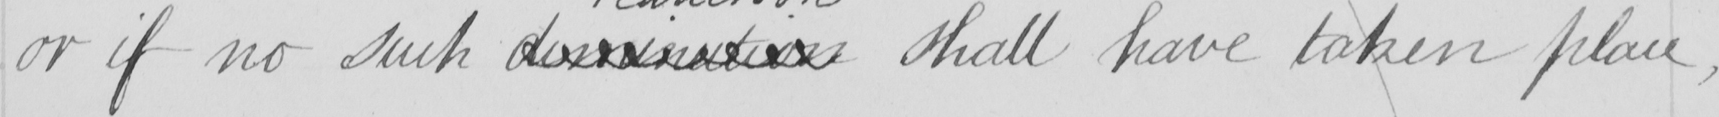Can you read and transcribe this handwriting? or if no such dominution shall have taken place  , 